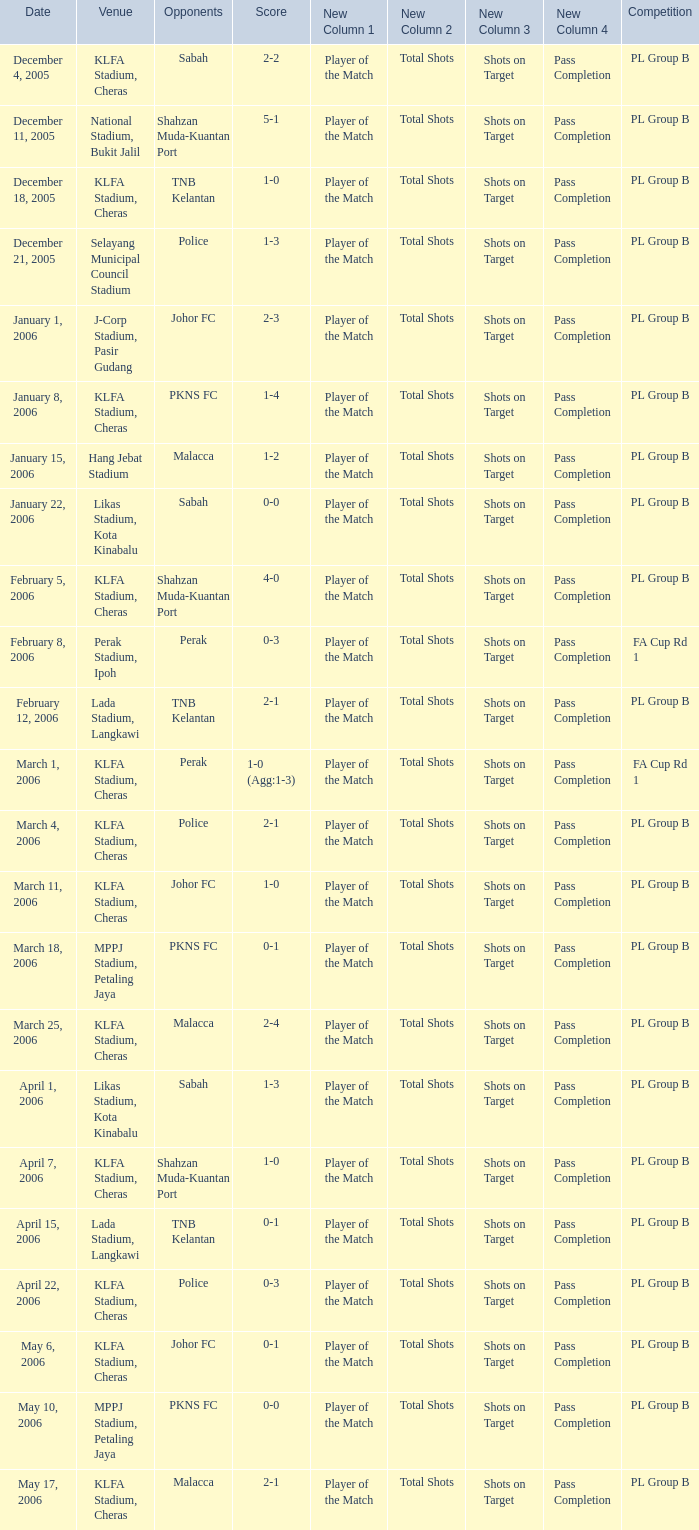Which Competition has a Score of 0-1, and Opponents of pkns fc? PL Group B. 